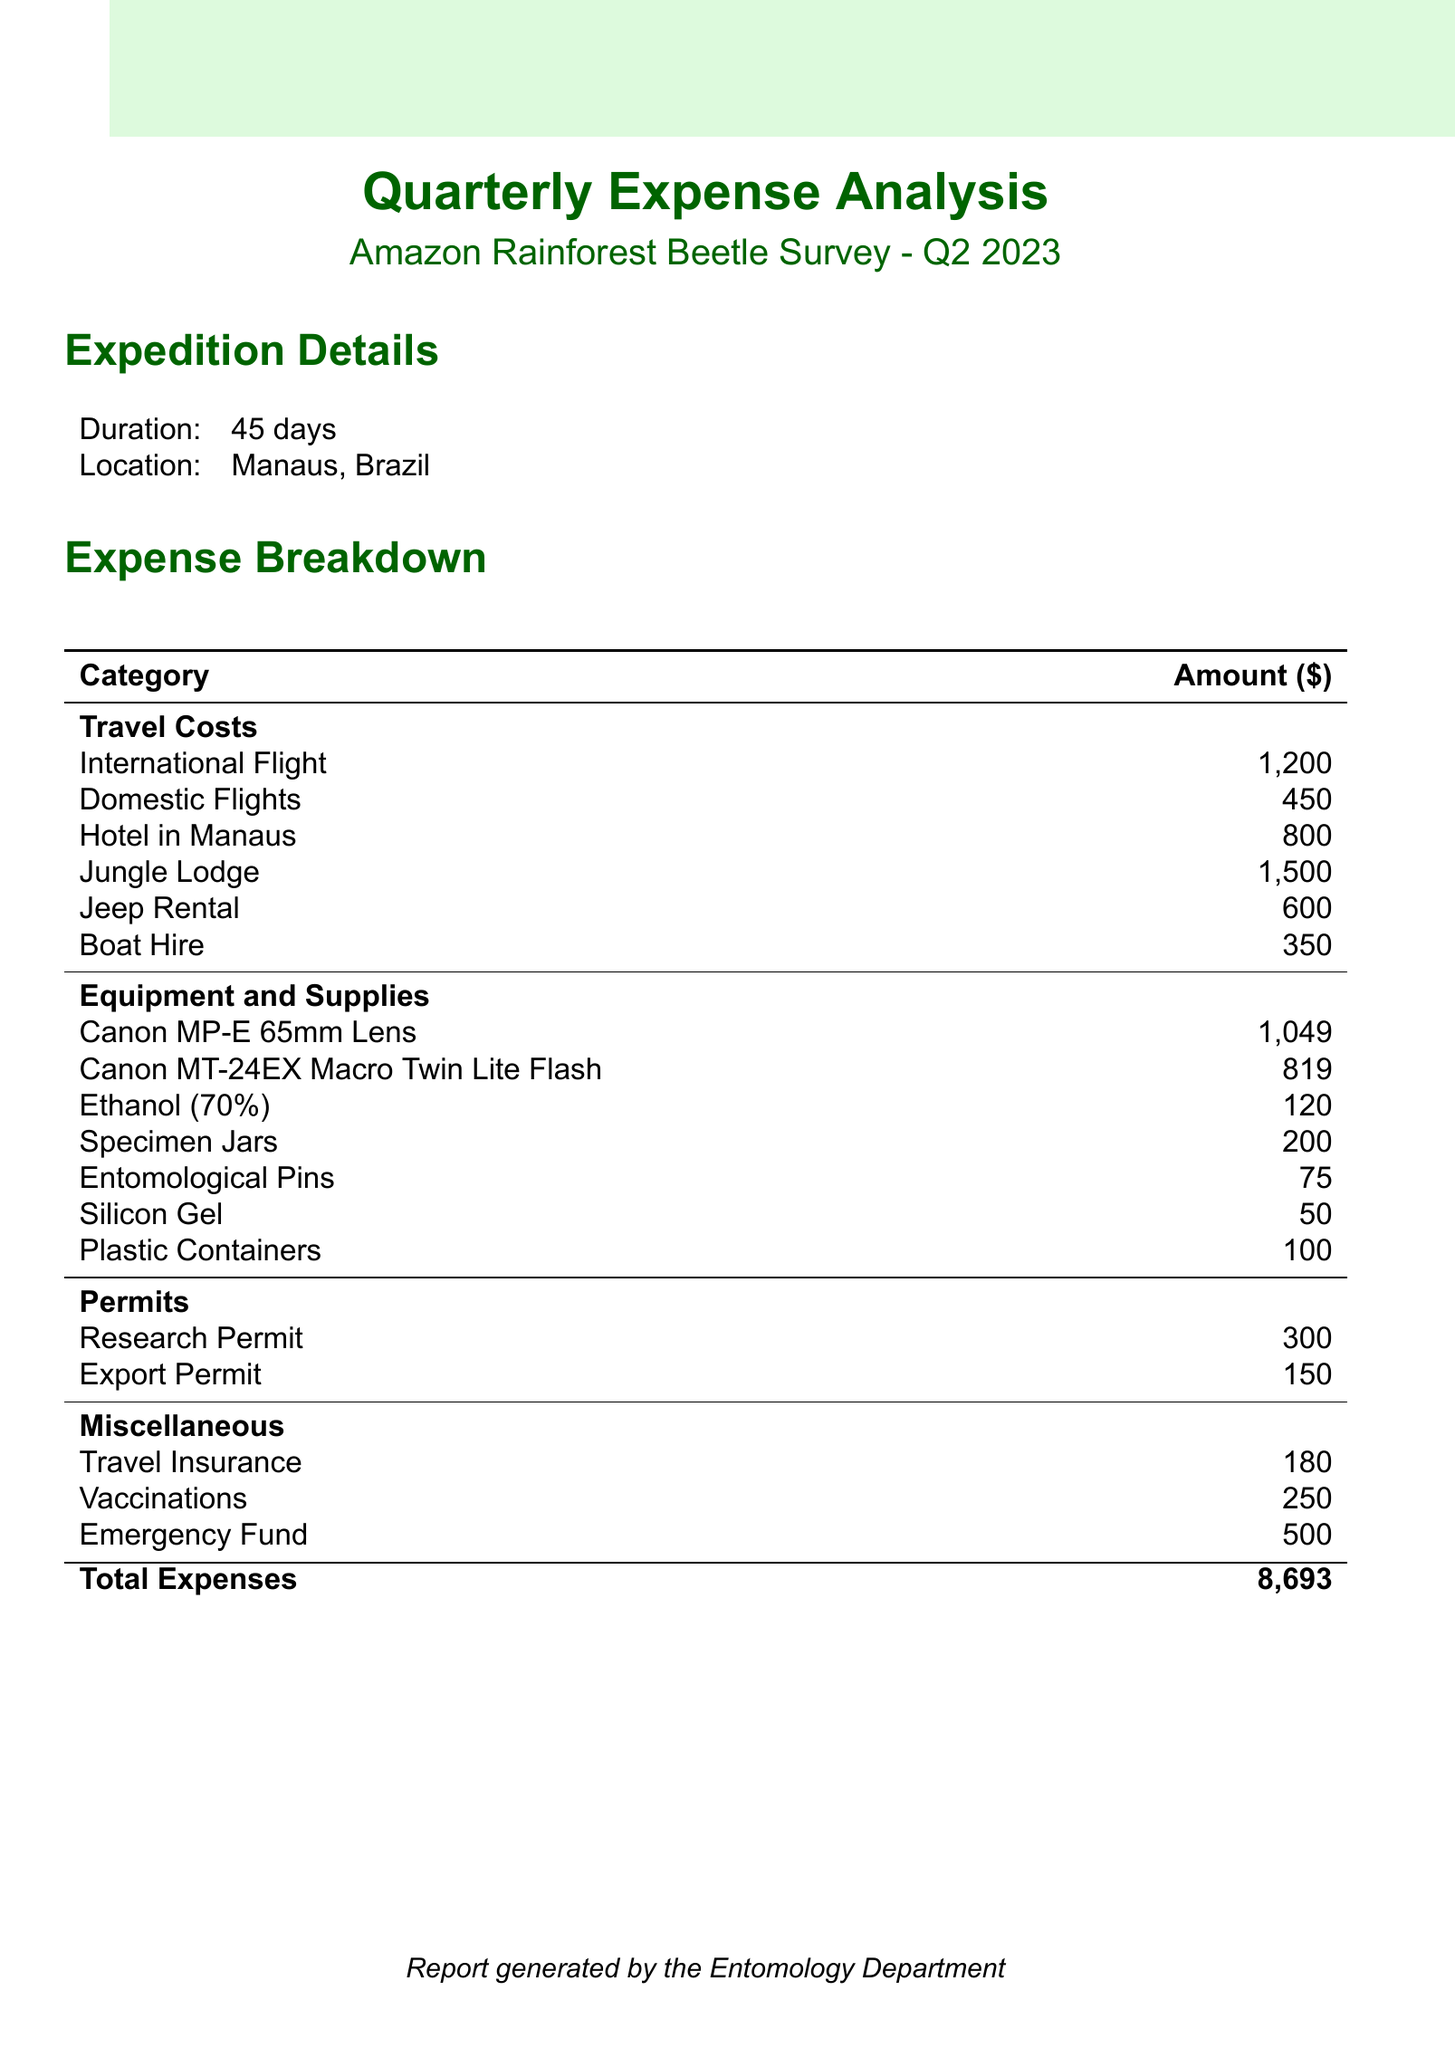what is the expedition name? The expedition name is provided in the expedition details section of the document.
Answer: Amazon Rainforest Beetle Survey what is the total expenses? The total expenses are calculated by summing up all categories of costs listed in the report.
Answer: 8693 how much was spent on international flights? The amount spent on international flights is explicitly mentioned under travel costs.
Answer: 1200 what is the duration of the expedition? The duration of the expedition is mentioned in the expedition details section.
Answer: 45 days how much did the Canon MP-E 65mm Lens cost? The cost of the Canon MP-E 65mm Lens is listed under the equipment and supplies category.
Answer: 1049 what are the miscellaneous expenses total? The miscellaneous expenses are the sum of individual costs listed under that category in the document.
Answer: 930 how much was spent on specimen jars? The expenditure on specimen jars is specifically noted in the equipment and supplies section.
Answer: 200 what is the location of the expedition? The location is identified in the expedition details section of the document.
Answer: Manaus, Brazil how many permits were obtained for the expedition? The total number of permits can be inferred from the number of permit types listed in the report.
Answer: 2 